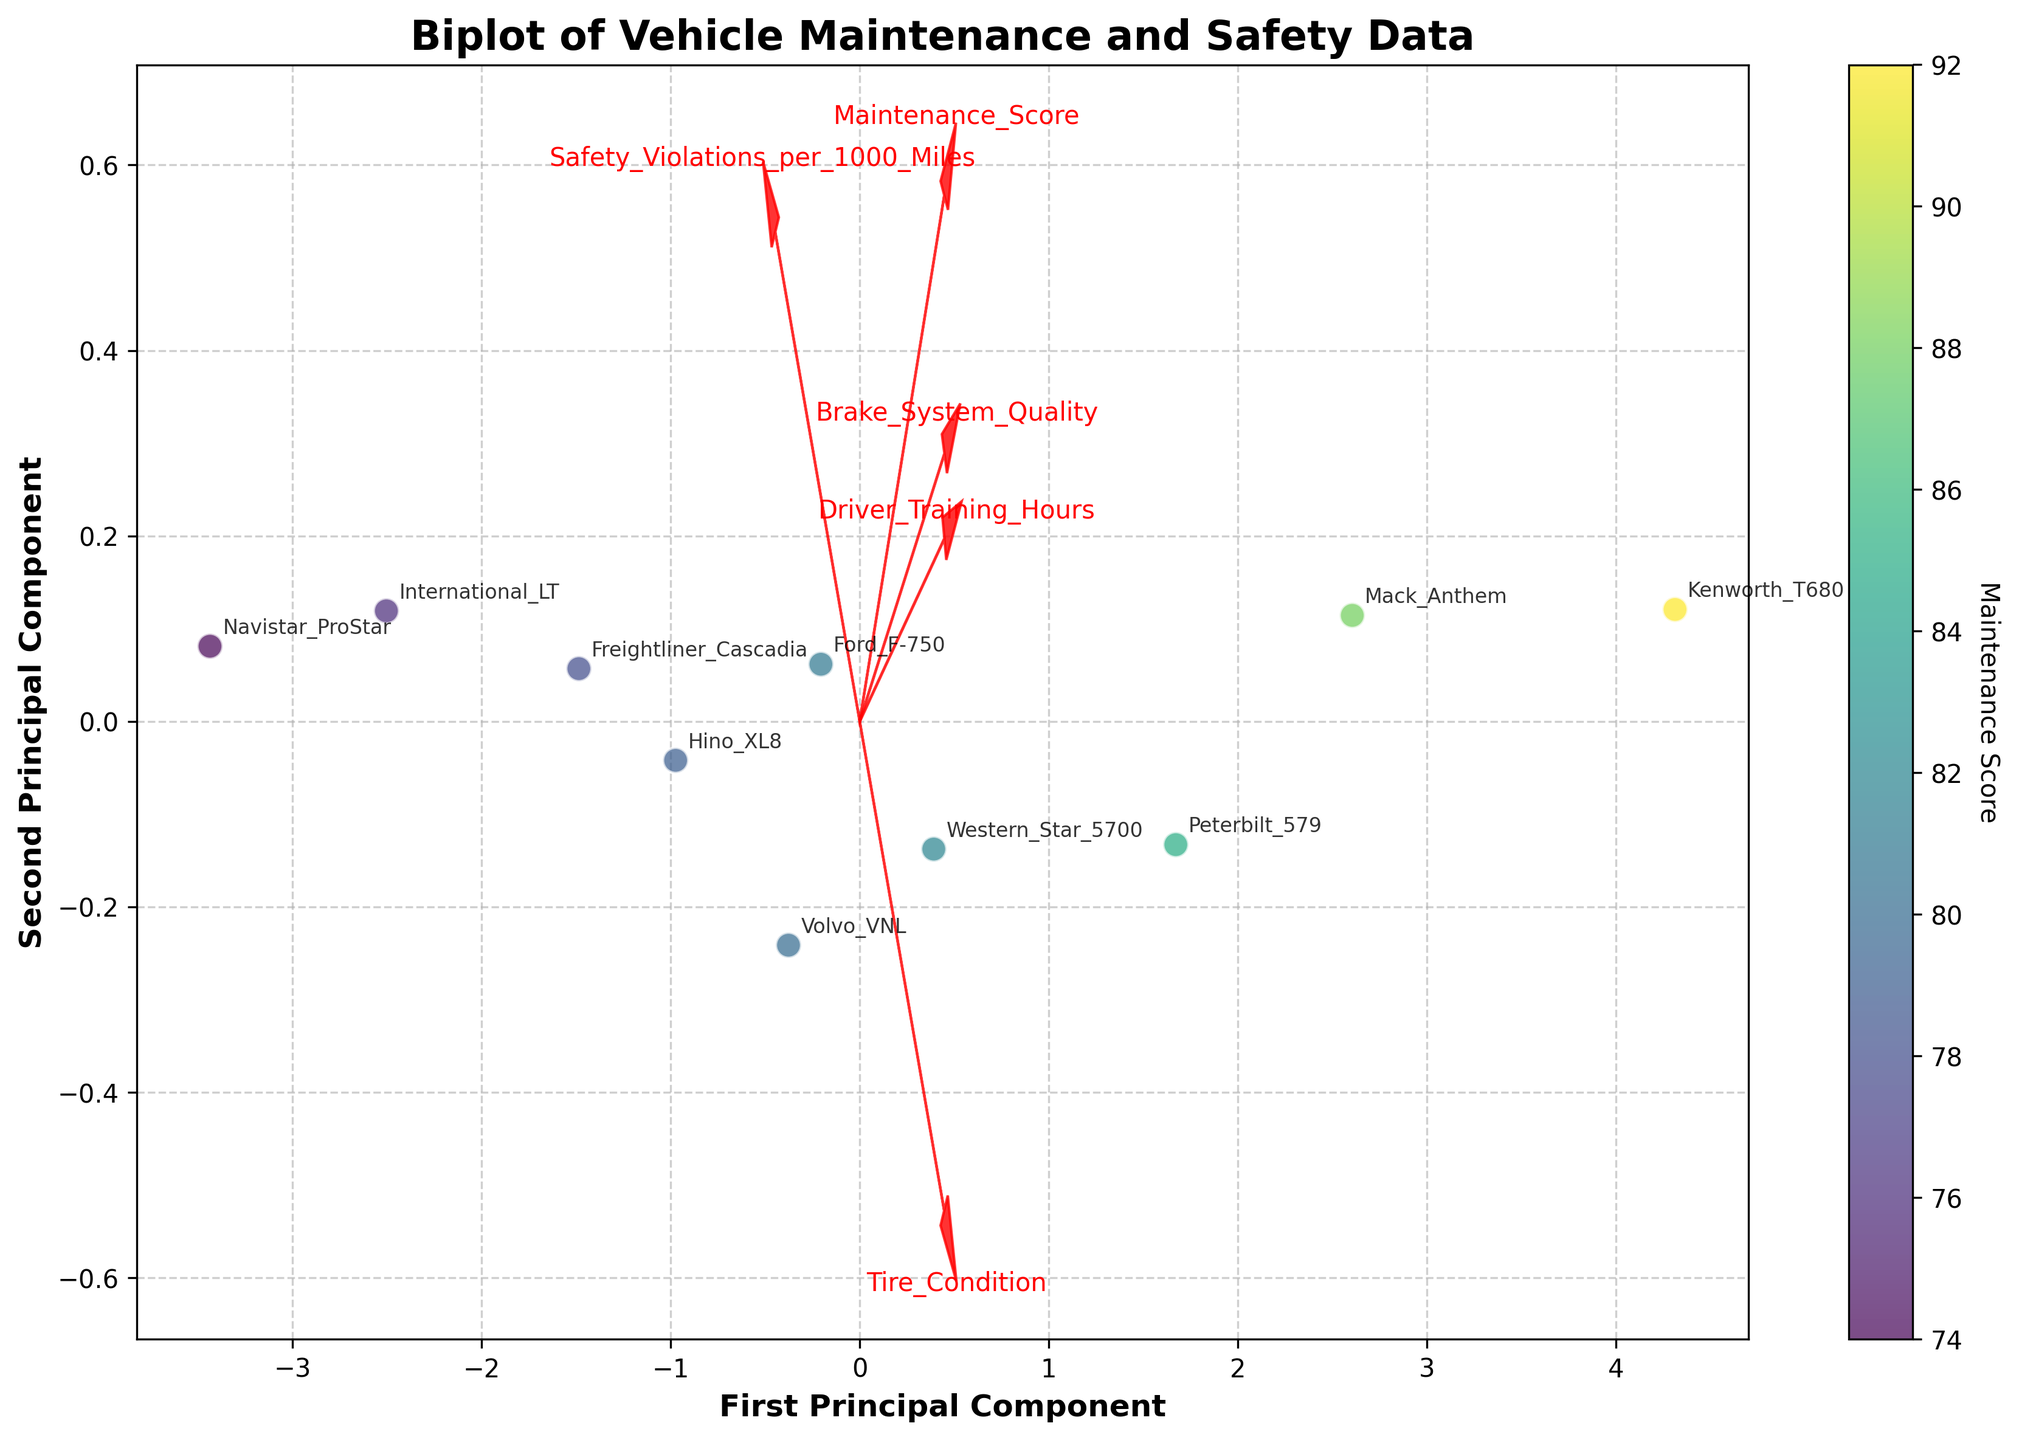What is the title of the figure? The title is usually found at the top of the plot. Here, it clearly states "Biplot of Vehicle Maintenance and Safety Data."
Answer: Biplot of Vehicle Maintenance and Safety Data How many principal components are displayed on the axes? The axes are labeled "First Principal Component" and "Second Principal Component," indicating that the plot visualizes data along these two principal components.
Answer: Two Which vehicle has the highest Maintenance Score? By examining the color gradient on the scatter plot, the vehicle with the highest Maintenance Score is represented by the darkest color. This corresponds to the Kenworth_T680.
Answer: Kenworth_T680 Which feature vector points most in the direction of the "First Principal Component"? We look at the arrows pointing from the origin. The feature vector with the longest projection on the First Principal Component axis is the one for "Maintenance_Score."
Answer: Maintenance_Score Does higher Maintenance Score correlate with fewer Safety Violations per 1000 Miles? Observing the scatter plot, darker colors (higher Maintenance Scores) generally appear towards the lower part of the vertical axis (fewer Safety Violations).
Answer: Yes What do the arrows in the plot represent? The arrows represent feature vectors showing the direction and magnitude (loadings) of each feature on the principal components. Longer arrows indicate stronger influence in that direction.
Answer: Feature vectors Which feature does not seem strongly correlated with the second principal component? We look for the feature vector that has a small projection on the Second Principal Component axis. This corresponds to "Driver_Training_Hours."
Answer: Driver_Training_Hours Which vehicle has the highest number of Safety Violations per 1000 Miles? The plot labels each point. By identifying the point representing the highest position on the vertical axis, we find it corresponds to Navistar_ProStar.
Answer: Navistar_ProStar Given the plot, which feature could be emphasized to improve safety with fewer violations? By examining the direction of vectors, improving "Driver_Training_Hours" would likely push points towards better safety, as indicated by the direction of this feature's vector.
Answer: Driver_Training_Hours 